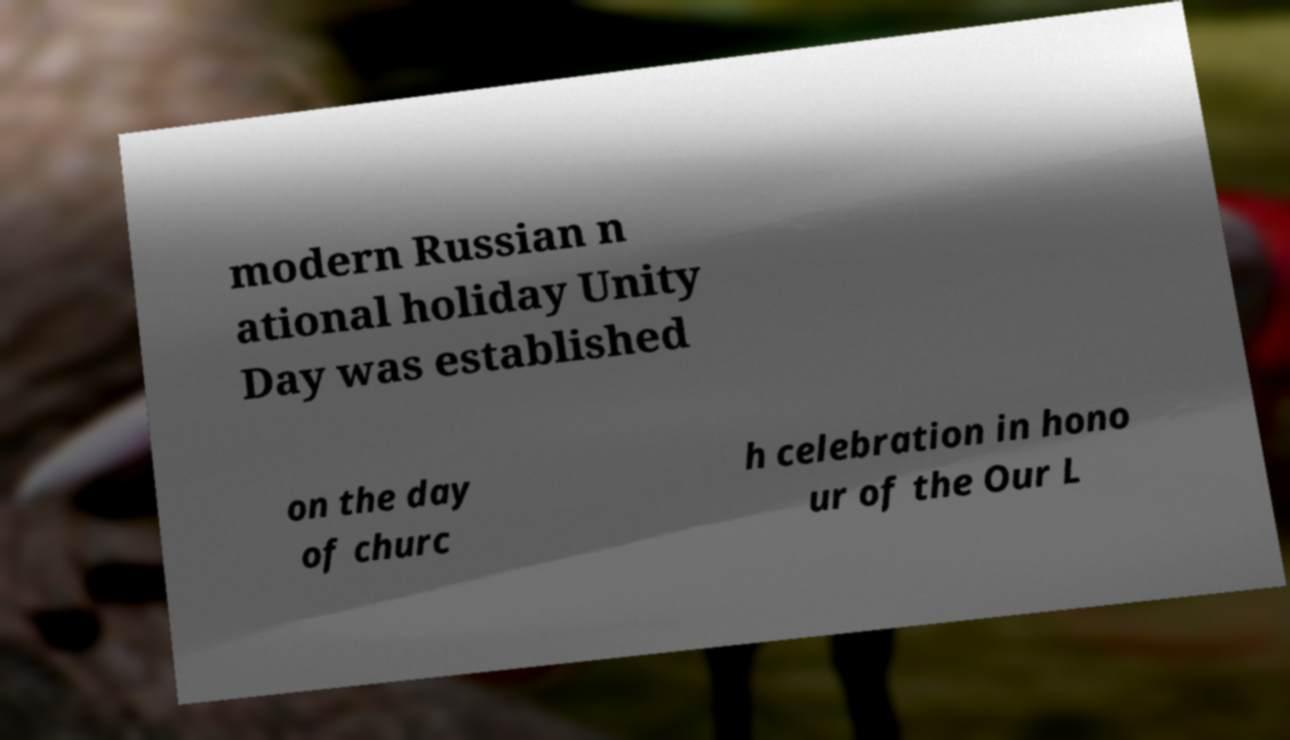For documentation purposes, I need the text within this image transcribed. Could you provide that? modern Russian n ational holiday Unity Day was established on the day of churc h celebration in hono ur of the Our L 